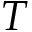Convert formula to latex. <formula><loc_0><loc_0><loc_500><loc_500>T</formula> 